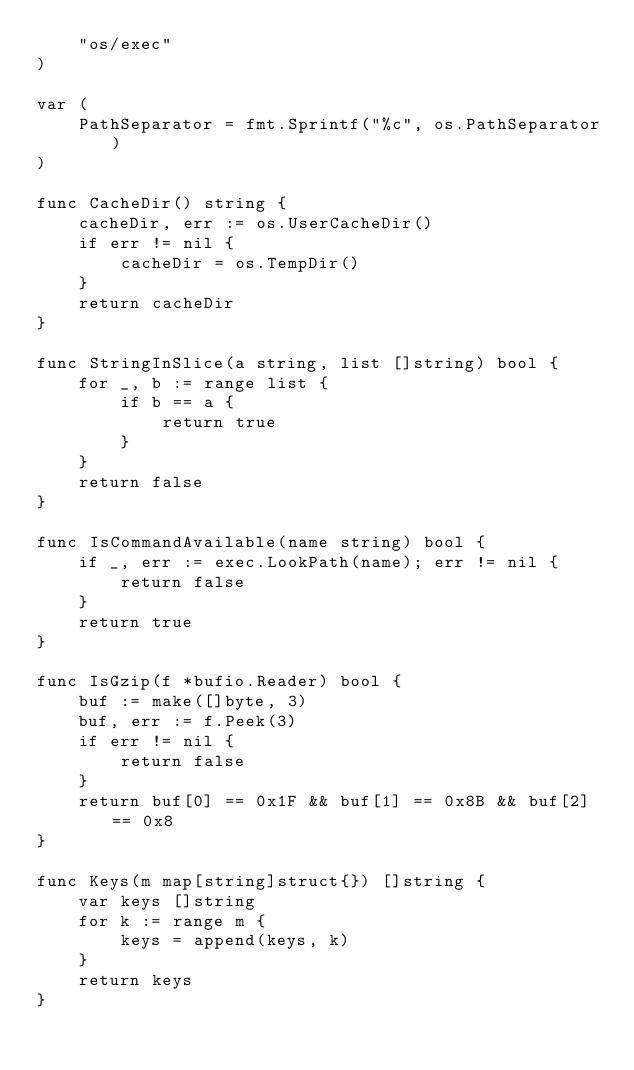Convert code to text. <code><loc_0><loc_0><loc_500><loc_500><_Go_>	"os/exec"
)

var (
	PathSeparator = fmt.Sprintf("%c", os.PathSeparator)
)

func CacheDir() string {
	cacheDir, err := os.UserCacheDir()
	if err != nil {
		cacheDir = os.TempDir()
	}
	return cacheDir
}

func StringInSlice(a string, list []string) bool {
	for _, b := range list {
		if b == a {
			return true
		}
	}
	return false
}

func IsCommandAvailable(name string) bool {
	if _, err := exec.LookPath(name); err != nil {
		return false
	}
	return true
}

func IsGzip(f *bufio.Reader) bool {
	buf := make([]byte, 3)
	buf, err := f.Peek(3)
	if err != nil {
		return false
	}
	return buf[0] == 0x1F && buf[1] == 0x8B && buf[2] == 0x8
}

func Keys(m map[string]struct{}) []string {
	var keys []string
	for k := range m {
		keys = append(keys, k)
	}
	return keys
}
</code> 